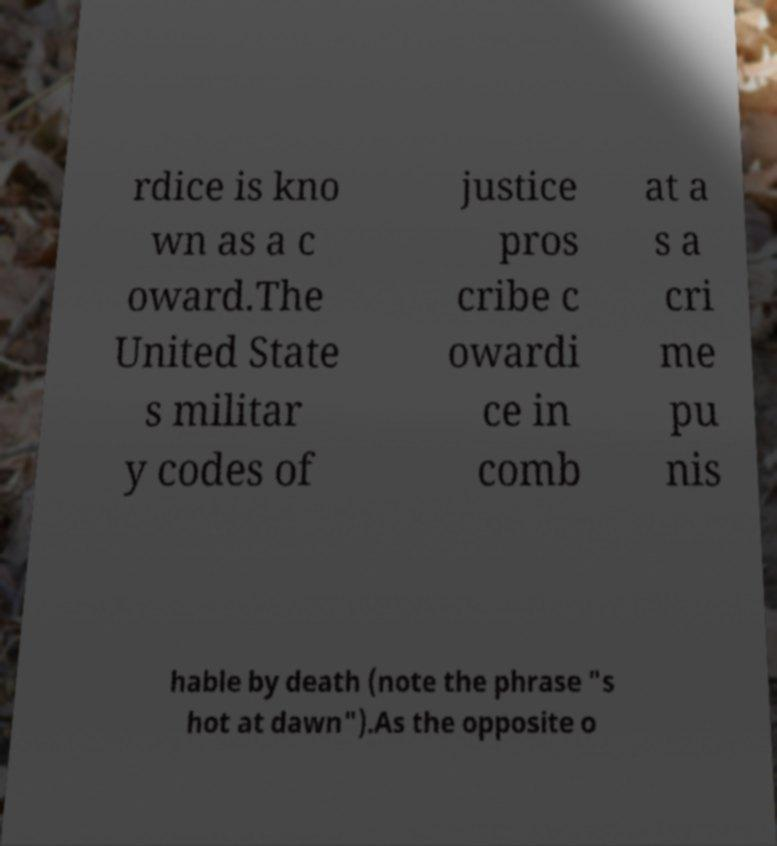What messages or text are displayed in this image? I need them in a readable, typed format. rdice is kno wn as a c oward.The United State s militar y codes of justice pros cribe c owardi ce in comb at a s a cri me pu nis hable by death (note the phrase "s hot at dawn").As the opposite o 